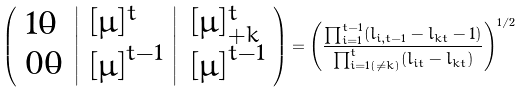<formula> <loc_0><loc_0><loc_500><loc_500>\left ( \begin{array} { l } 1 \dot { 0 } \\ 0 \dot { 0 } \end{array} \left | \begin{array} { l } [ \mu ] ^ { t } \\ { [ \mu ] } ^ { t - 1 } \end{array} \right | \begin{array} { l } [ \mu ] ^ { t } _ { + k } \\ { [ \mu ] } ^ { t - 1 } \end{array} \right ) = \left ( \frac { \prod _ { i = 1 } ^ { t - 1 } ( l _ { i , t - 1 } - l _ { k t } - 1 ) } { \prod _ { i = 1 ( \neq k ) } ^ { t } ( l _ { i t } - l _ { k t } ) } \right ) ^ { 1 / 2 }</formula> 